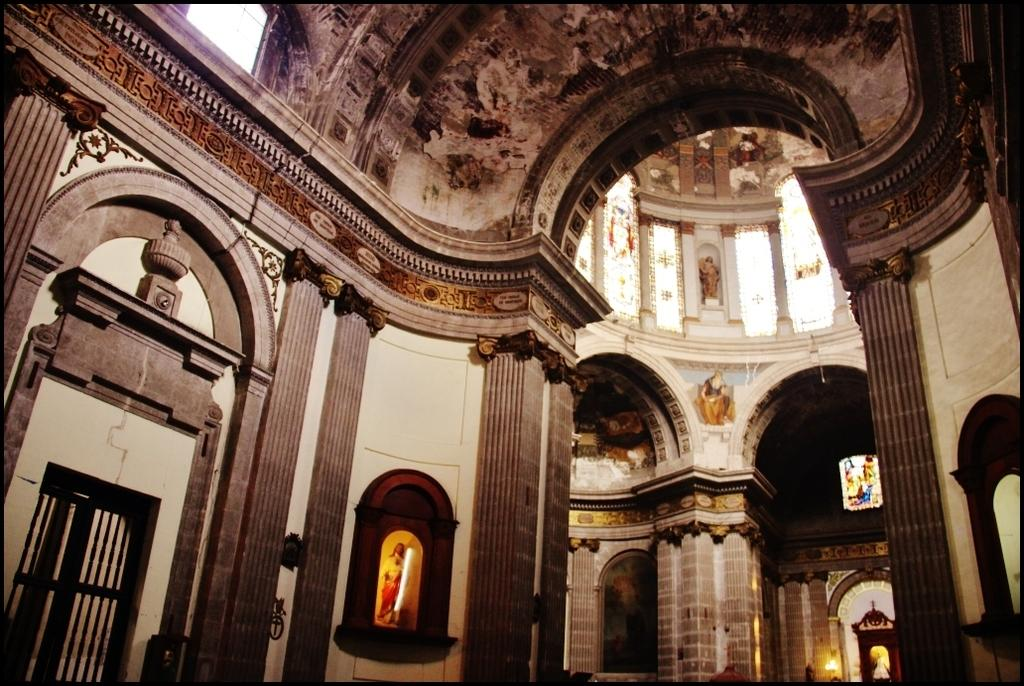What type of location is depicted in the image? The image shows the inside of a building. What architectural feature can be seen in the image? There are windows visible in the image. What decorative items are present in the image? There are statues on a shelf in the image. What is the plot of the story being told in the image? There is no story being told in the image; it is a static representation of the inside of a building with windows and statues on a shelf. 